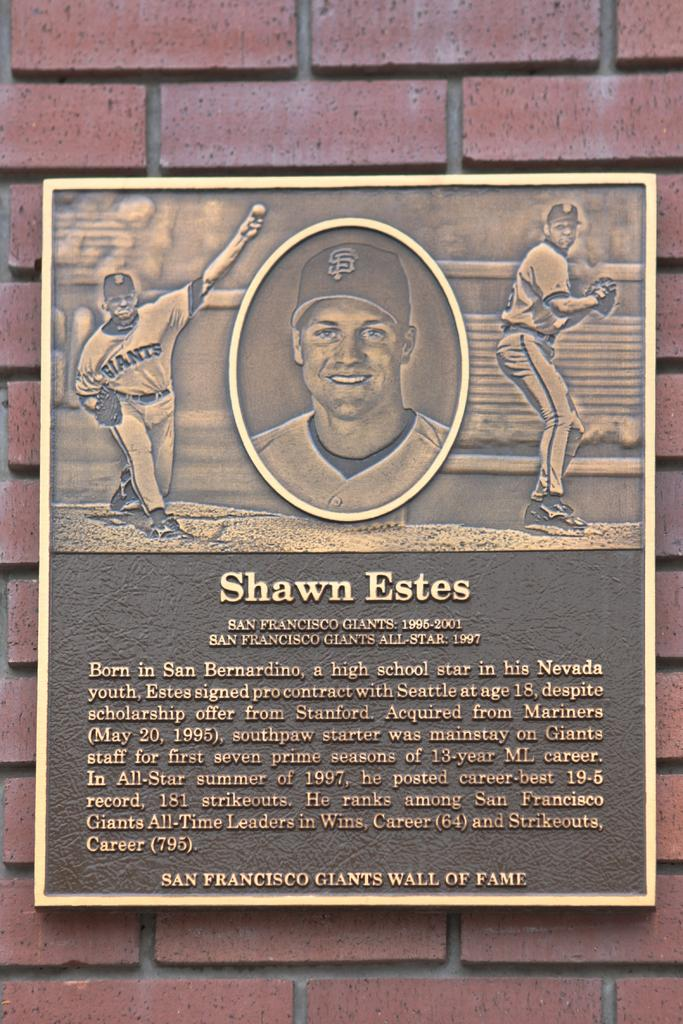<image>
Render a clear and concise summary of the photo. A plaque commemorating Shawn Estes hangs on a brick wall. 